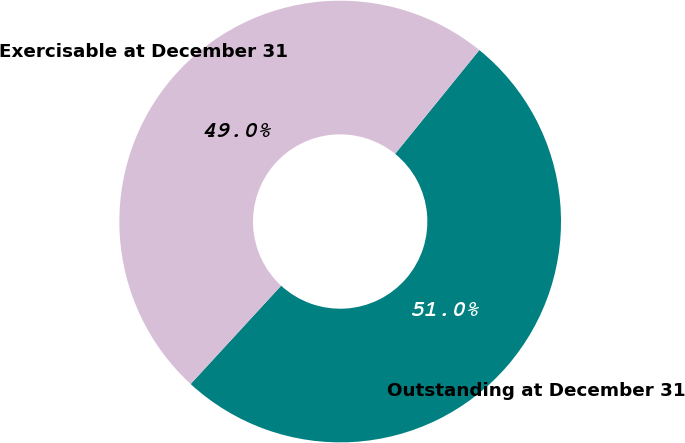Convert chart. <chart><loc_0><loc_0><loc_500><loc_500><pie_chart><fcel>Outstanding at December 31<fcel>Exercisable at December 31<nl><fcel>50.99%<fcel>49.01%<nl></chart> 